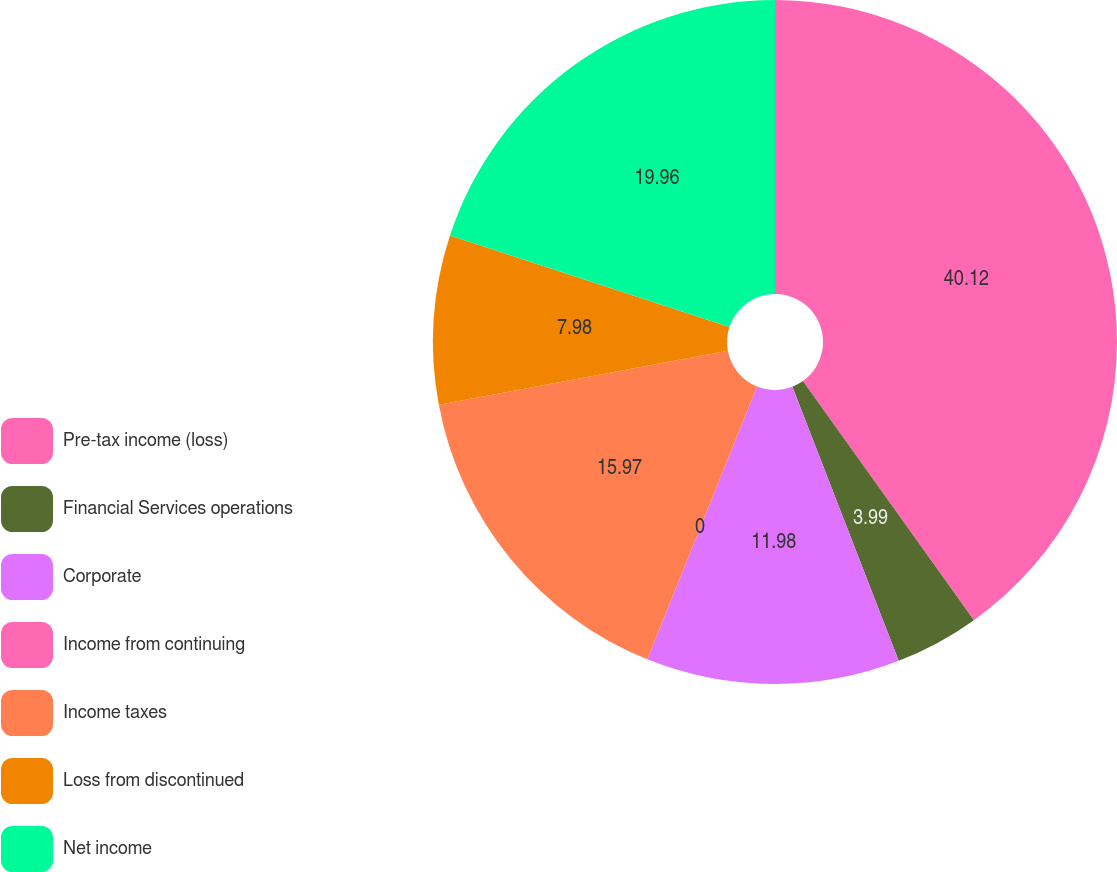<chart> <loc_0><loc_0><loc_500><loc_500><pie_chart><fcel>Pre-tax income (loss)<fcel>Financial Services operations<fcel>Corporate<fcel>Income from continuing<fcel>Income taxes<fcel>Loss from discontinued<fcel>Net income<nl><fcel>40.12%<fcel>3.99%<fcel>11.98%<fcel>0.0%<fcel>15.97%<fcel>7.98%<fcel>19.96%<nl></chart> 